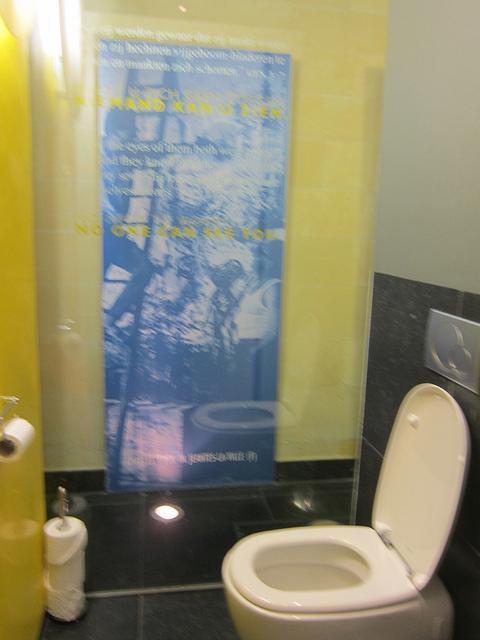How many rolls of toilet paper do you see?
Give a very brief answer. 4. How many toilets can be seen?
Give a very brief answer. 2. 